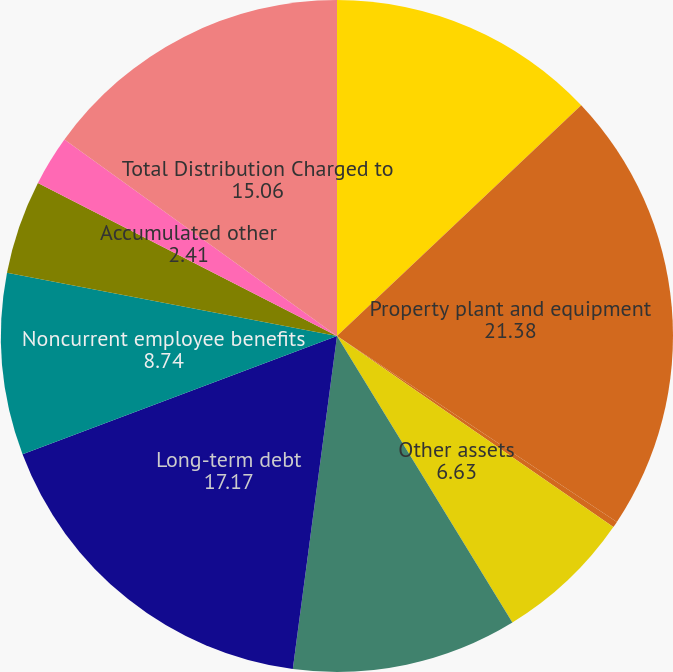<chart> <loc_0><loc_0><loc_500><loc_500><pie_chart><fcel>Current assets<fcel>Property plant and equipment<fcel>Timberlands<fcel>Other assets<fcel>Current liabilities<fcel>Long-term debt<fcel>Noncurrent employee benefits<fcel>Deferred income taxes and<fcel>Accumulated other<fcel>Total Distribution Charged to<nl><fcel>12.95%<fcel>21.38%<fcel>0.3%<fcel>6.63%<fcel>10.84%<fcel>17.17%<fcel>8.74%<fcel>4.52%<fcel>2.41%<fcel>15.06%<nl></chart> 